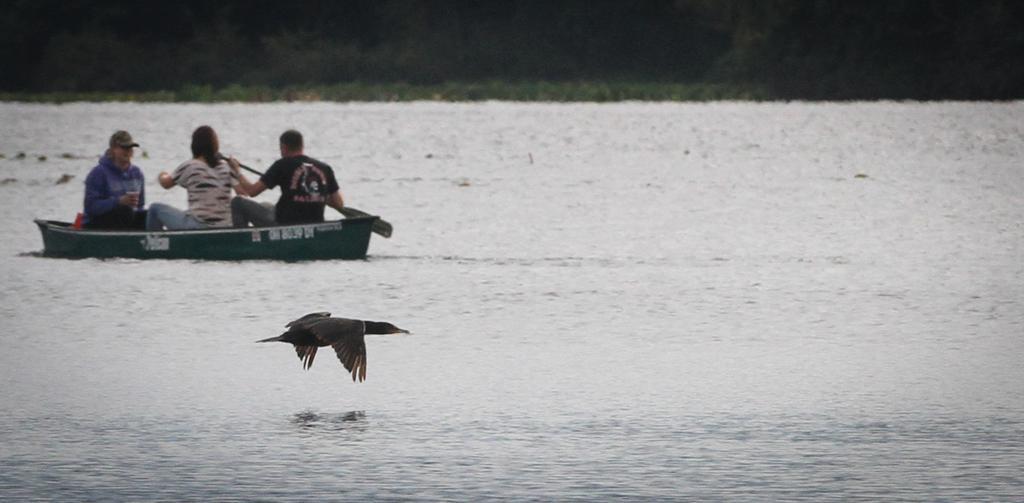Could you give a brief overview of what you see in this image? In this image there is a bird flying in the front. In the background there is a boat and there are persons sitting on the boat. The man wearing a black colour t-shirt is rowing a boat. In the background there are trees. 